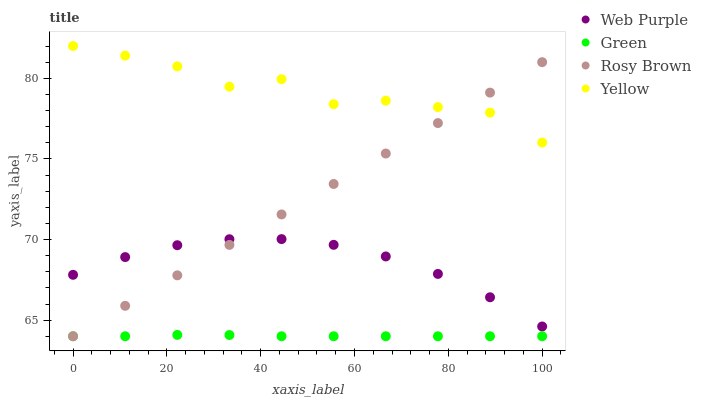Does Green have the minimum area under the curve?
Answer yes or no. Yes. Does Yellow have the maximum area under the curve?
Answer yes or no. Yes. Does Rosy Brown have the minimum area under the curve?
Answer yes or no. No. Does Rosy Brown have the maximum area under the curve?
Answer yes or no. No. Is Rosy Brown the smoothest?
Answer yes or no. Yes. Is Yellow the roughest?
Answer yes or no. Yes. Is Green the smoothest?
Answer yes or no. No. Is Green the roughest?
Answer yes or no. No. Does Rosy Brown have the lowest value?
Answer yes or no. Yes. Does Yellow have the lowest value?
Answer yes or no. No. Does Yellow have the highest value?
Answer yes or no. Yes. Does Rosy Brown have the highest value?
Answer yes or no. No. Is Green less than Yellow?
Answer yes or no. Yes. Is Yellow greater than Web Purple?
Answer yes or no. Yes. Does Rosy Brown intersect Web Purple?
Answer yes or no. Yes. Is Rosy Brown less than Web Purple?
Answer yes or no. No. Is Rosy Brown greater than Web Purple?
Answer yes or no. No. Does Green intersect Yellow?
Answer yes or no. No. 